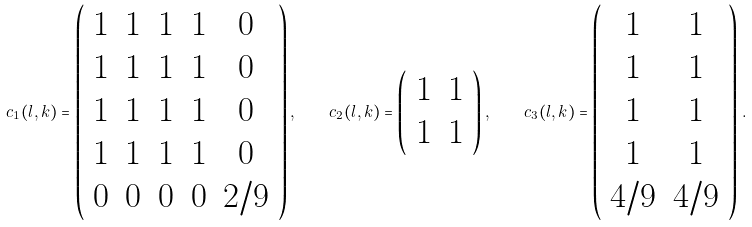<formula> <loc_0><loc_0><loc_500><loc_500>c _ { 1 } ( l , k ) = \left ( \begin{array} { c c c c c } 1 & 1 & 1 & 1 & 0 \\ 1 & 1 & 1 & 1 & 0 \\ 1 & 1 & 1 & 1 & 0 \\ 1 & 1 & 1 & 1 & 0 \\ 0 & 0 & 0 & 0 & 2 / 9 \end{array} \right ) , \quad c _ { 2 } ( l , k ) = \left ( \begin{array} { c c } 1 & 1 \\ 1 & 1 \end{array} \right ) , \quad c _ { 3 } ( l , k ) = \left ( \begin{array} { c c } 1 & 1 \\ 1 & 1 \\ 1 & 1 \\ 1 & 1 \\ 4 / 9 & 4 / 9 \end{array} \right ) \, .</formula> 